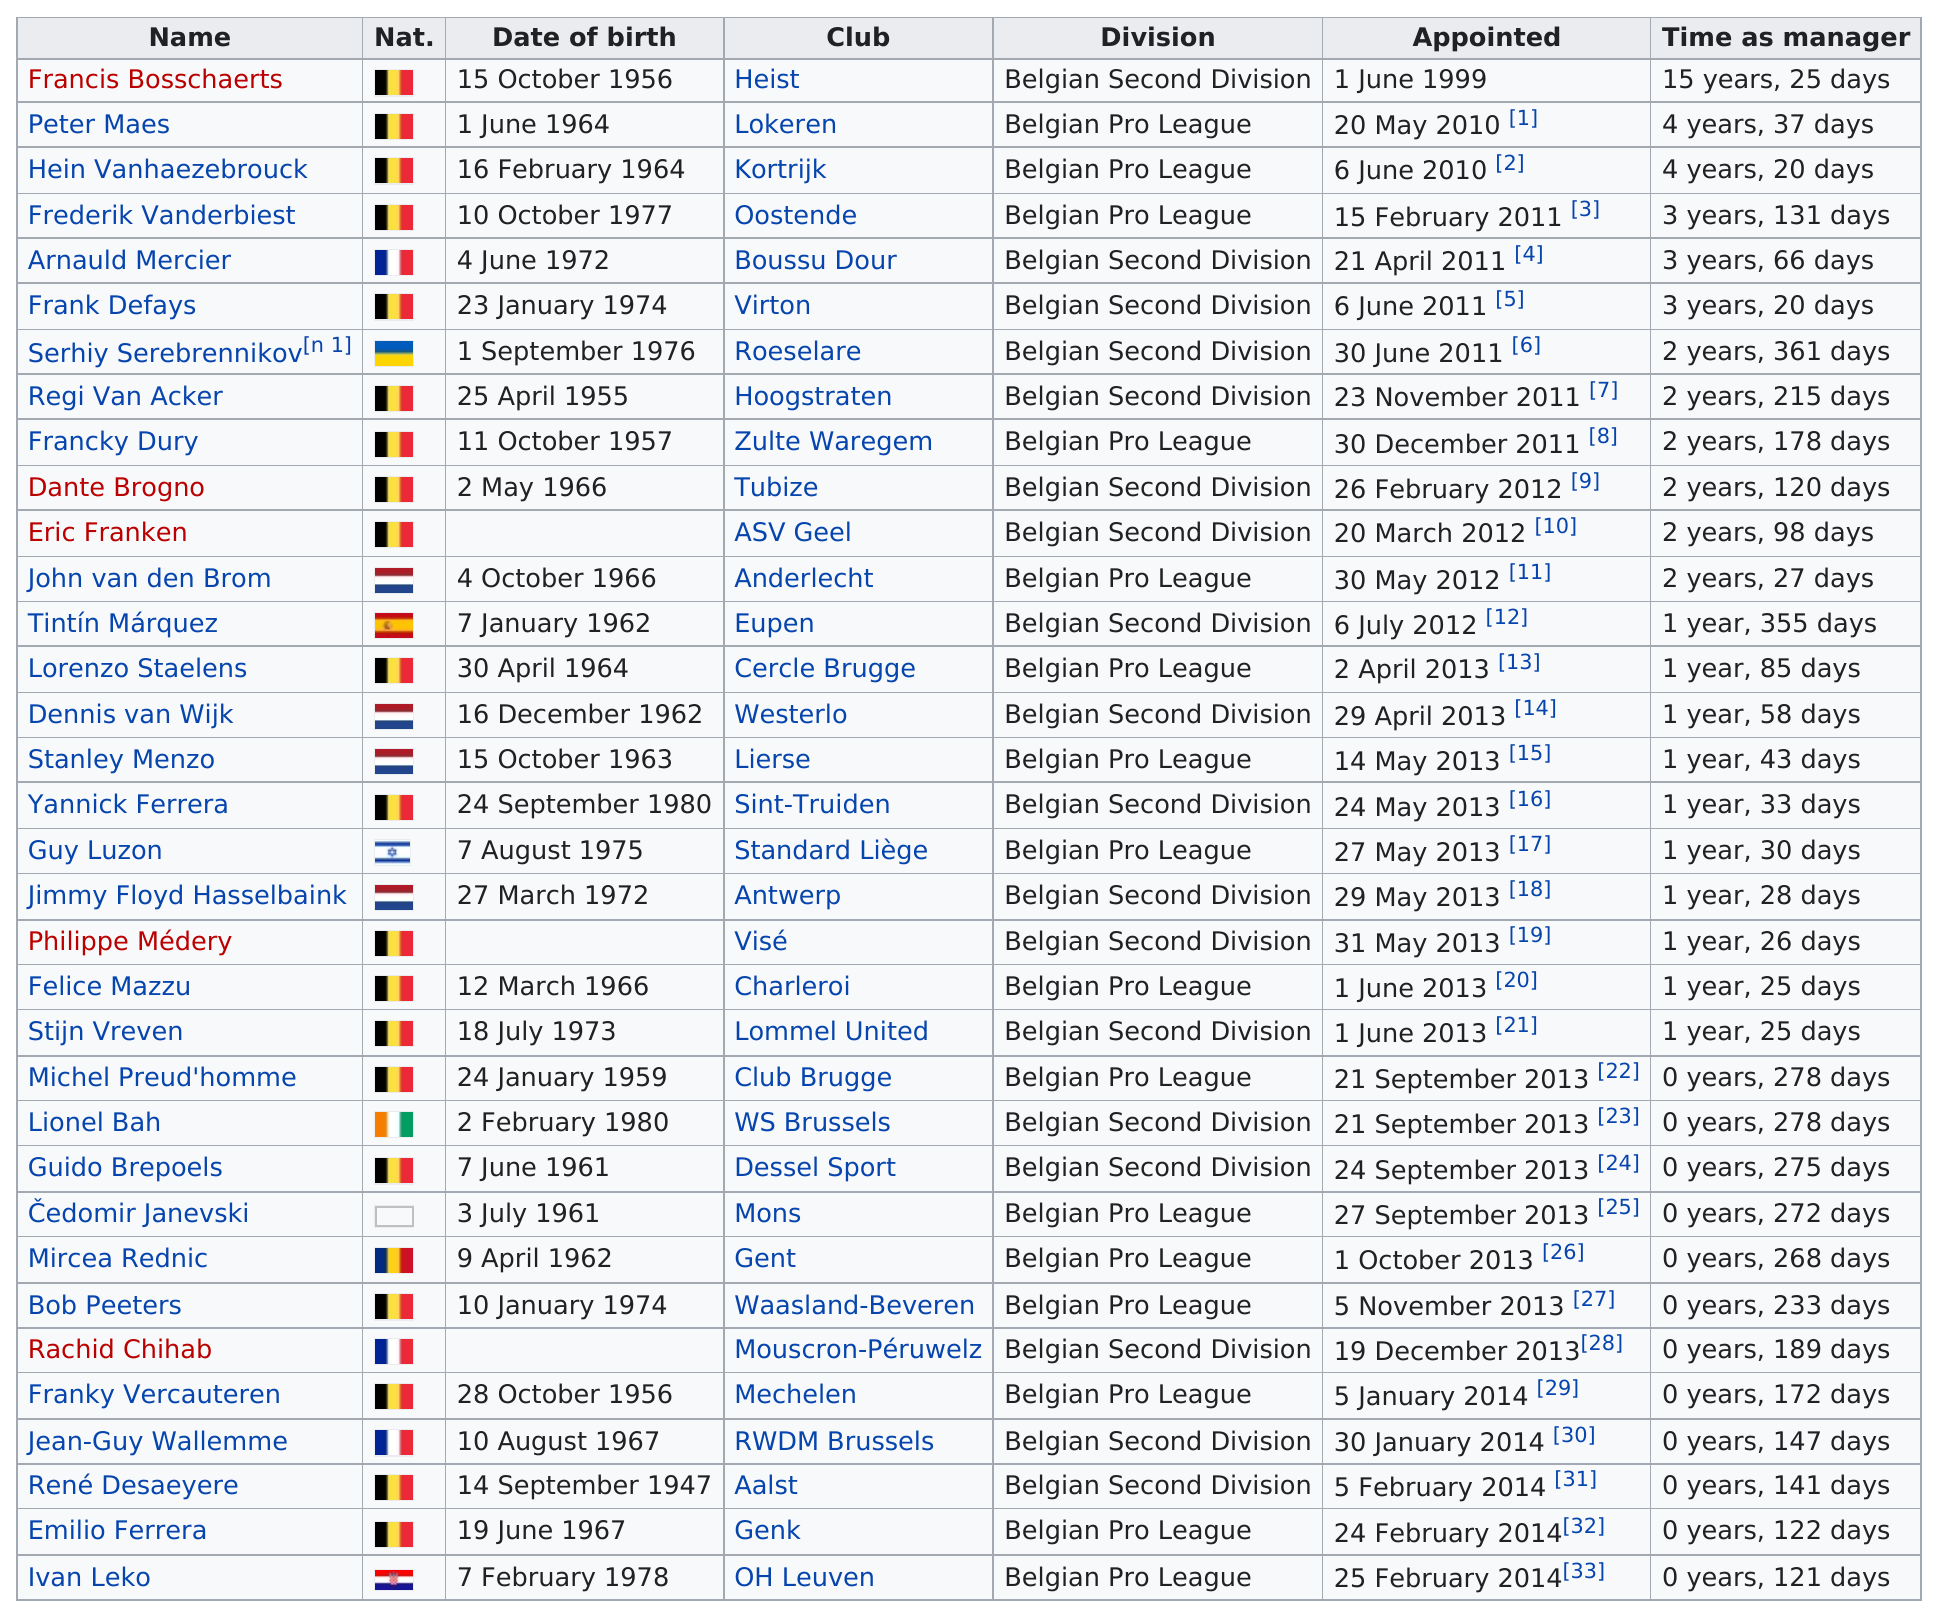Highlight a few significant elements in this photo. Frank Defays has served as manager for 3 years and 20 days. Francis Bosschaerts served as the manager for a longer period than Peter Maes. Francis Bosschaerts has been a manager for the longest period of time. Francis Bosschaerts was appointed as the first manager. Francis Bosschaerts is older than Peter Maes. 